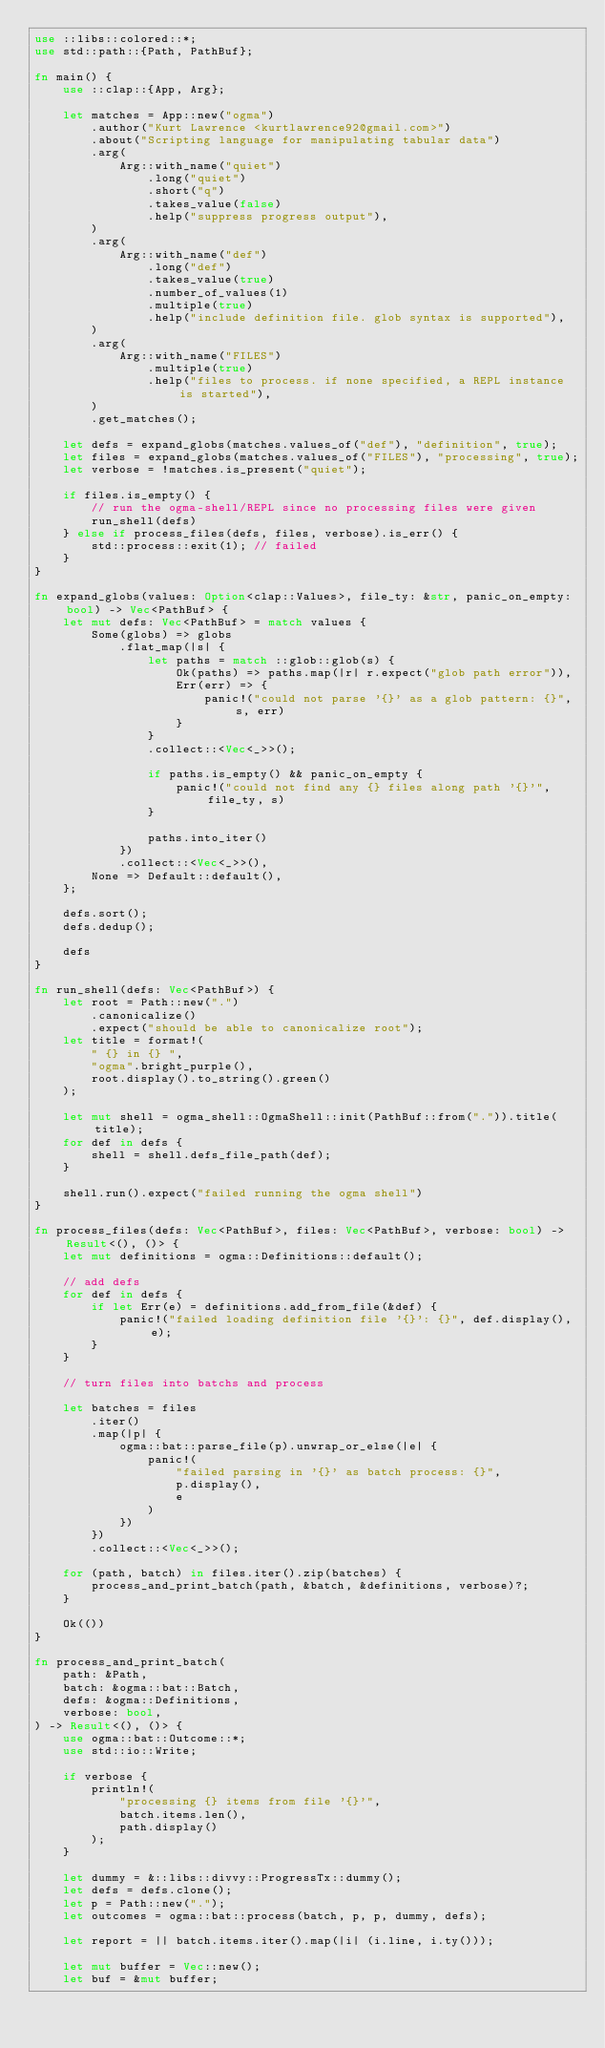<code> <loc_0><loc_0><loc_500><loc_500><_Rust_>use ::libs::colored::*;
use std::path::{Path, PathBuf};

fn main() {
    use ::clap::{App, Arg};

    let matches = App::new("ogma")
        .author("Kurt Lawrence <kurtlawrence92@gmail.com>")
        .about("Scripting language for manipulating tabular data")
        .arg(
            Arg::with_name("quiet")
                .long("quiet")
                .short("q")
                .takes_value(false)
                .help("suppress progress output"),
        )
        .arg(
            Arg::with_name("def")
                .long("def")
                .takes_value(true)
                .number_of_values(1)
                .multiple(true)
                .help("include definition file. glob syntax is supported"),
        )
        .arg(
            Arg::with_name("FILES")
                .multiple(true)
                .help("files to process. if none specified, a REPL instance is started"),
        )
        .get_matches();

    let defs = expand_globs(matches.values_of("def"), "definition", true);
    let files = expand_globs(matches.values_of("FILES"), "processing", true);
    let verbose = !matches.is_present("quiet");

    if files.is_empty() {
        // run the ogma-shell/REPL since no processing files were given
        run_shell(defs)
    } else if process_files(defs, files, verbose).is_err() {
        std::process::exit(1); // failed
    }
}

fn expand_globs(values: Option<clap::Values>, file_ty: &str, panic_on_empty: bool) -> Vec<PathBuf> {
    let mut defs: Vec<PathBuf> = match values {
        Some(globs) => globs
            .flat_map(|s| {
                let paths = match ::glob::glob(s) {
                    Ok(paths) => paths.map(|r| r.expect("glob path error")),
                    Err(err) => {
                        panic!("could not parse '{}' as a glob pattern: {}", s, err)
                    }
                }
                .collect::<Vec<_>>();

                if paths.is_empty() && panic_on_empty {
                    panic!("could not find any {} files along path '{}'", file_ty, s)
                }

                paths.into_iter()
            })
            .collect::<Vec<_>>(),
        None => Default::default(),
    };

    defs.sort();
    defs.dedup();

    defs
}

fn run_shell(defs: Vec<PathBuf>) {
    let root = Path::new(".")
        .canonicalize()
        .expect("should be able to canonicalize root");
    let title = format!(
        " {} in {} ",
        "ogma".bright_purple(),
        root.display().to_string().green()
    );

    let mut shell = ogma_shell::OgmaShell::init(PathBuf::from(".")).title(title);
    for def in defs {
        shell = shell.defs_file_path(def);
    }

    shell.run().expect("failed running the ogma shell")
}

fn process_files(defs: Vec<PathBuf>, files: Vec<PathBuf>, verbose: bool) -> Result<(), ()> {
    let mut definitions = ogma::Definitions::default();

    // add defs
    for def in defs {
        if let Err(e) = definitions.add_from_file(&def) {
            panic!("failed loading definition file '{}': {}", def.display(), e);
        }
    }

    // turn files into batchs and process

    let batches = files
        .iter()
        .map(|p| {
            ogma::bat::parse_file(p).unwrap_or_else(|e| {
                panic!(
                    "failed parsing in '{}' as batch process: {}",
                    p.display(),
                    e
                )
            })
        })
        .collect::<Vec<_>>();

    for (path, batch) in files.iter().zip(batches) {
        process_and_print_batch(path, &batch, &definitions, verbose)?;
    }

    Ok(())
}

fn process_and_print_batch(
    path: &Path,
    batch: &ogma::bat::Batch,
    defs: &ogma::Definitions,
    verbose: bool,
) -> Result<(), ()> {
    use ogma::bat::Outcome::*;
    use std::io::Write;

    if verbose {
        println!(
            "processing {} items from file '{}'",
            batch.items.len(),
            path.display()
        );
    }

    let dummy = &::libs::divvy::ProgressTx::dummy();
    let defs = defs.clone();
    let p = Path::new(".");
    let outcomes = ogma::bat::process(batch, p, p, dummy, defs);

    let report = || batch.items.iter().map(|i| (i.line, i.ty()));

    let mut buffer = Vec::new();
    let buf = &mut buffer;</code> 